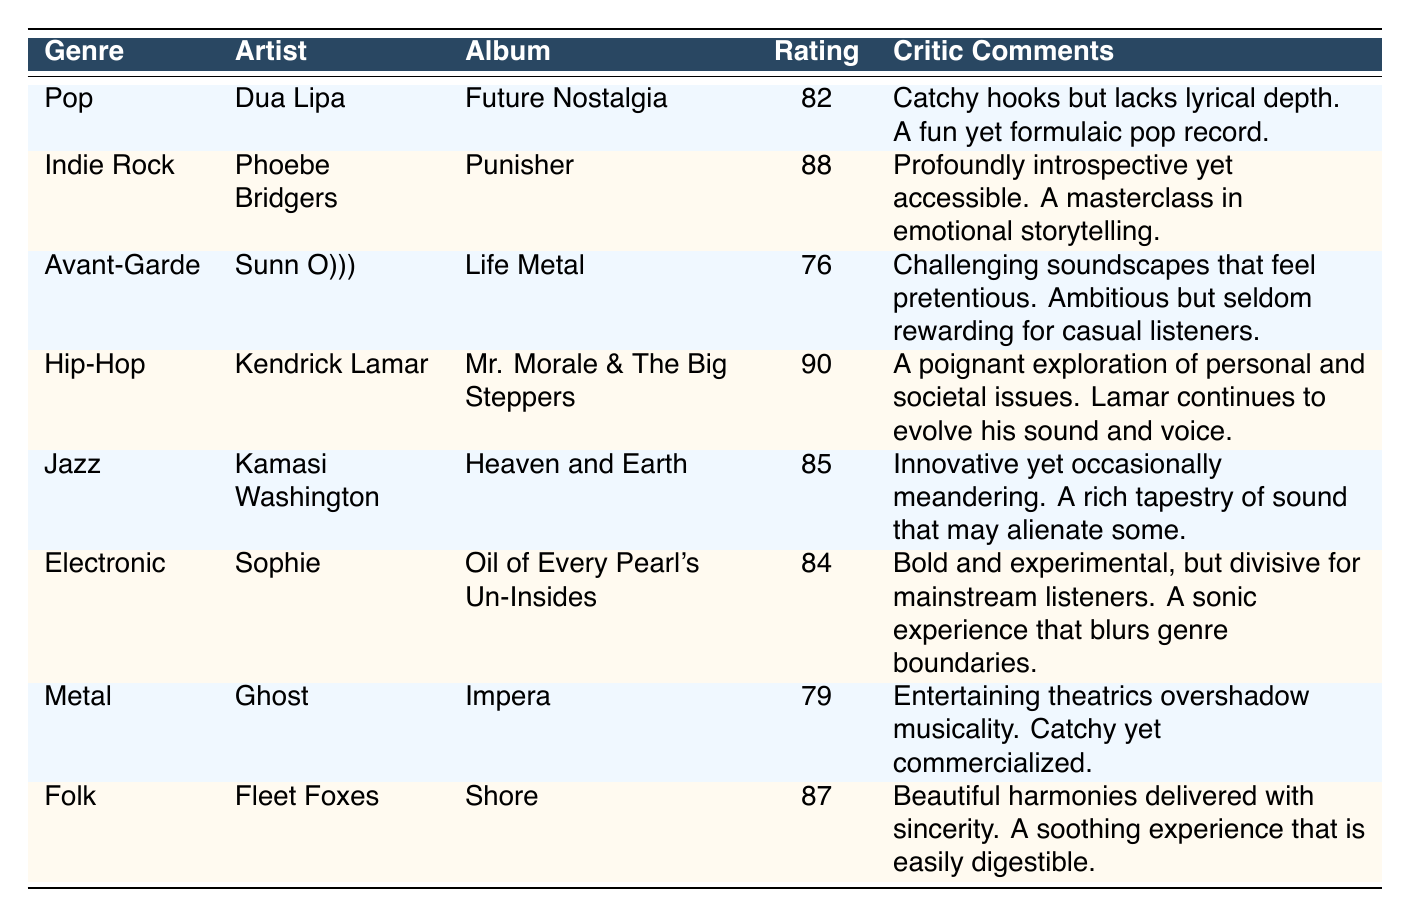What is the average rating of the Indie Rock genre? The table shows that Phoebe Bridgers' album "Punisher" under the Indie Rock genre has an average rating of 88. Since there is only one entry in that genre, the average rating is simply 88.
Answer: 88 How many genres have an average rating above 80? The genres with average ratings above 80 are Pop (82), Indie Rock (88), Hip-Hop (90), Jazz (85), Electronic (84), and Folk (87). Counting these entries gives us a total of 6 genres.
Answer: 6 Is there an album in the Jazz genre that has a rating of 85 or higher? The Jazz album "Heaven and Earth" by Kamasi Washington has an average rating of 85, which meets the condition of being 85 or higher. Therefore, the answer is yes.
Answer: Yes What is the rating difference between the highest-rated album and the lowest-rated album? The highest-rated album is Kendrick Lamar's "Mr. Morale & The Big Steppers" with a rating of 90, and the lowest-rated album is Sunn O)))'s "Life Metal" with a rating of 76. The difference is 90 - 76 = 14.
Answer: 14 Which genre has the most critic comments focusing on accessibility? The Indie Rock genre is highlighted by comments that refer to it as "profoundly introspective yet accessible." This suggests that it focuses on being accessible, more than any other genre present in the table.
Answer: Indie Rock 